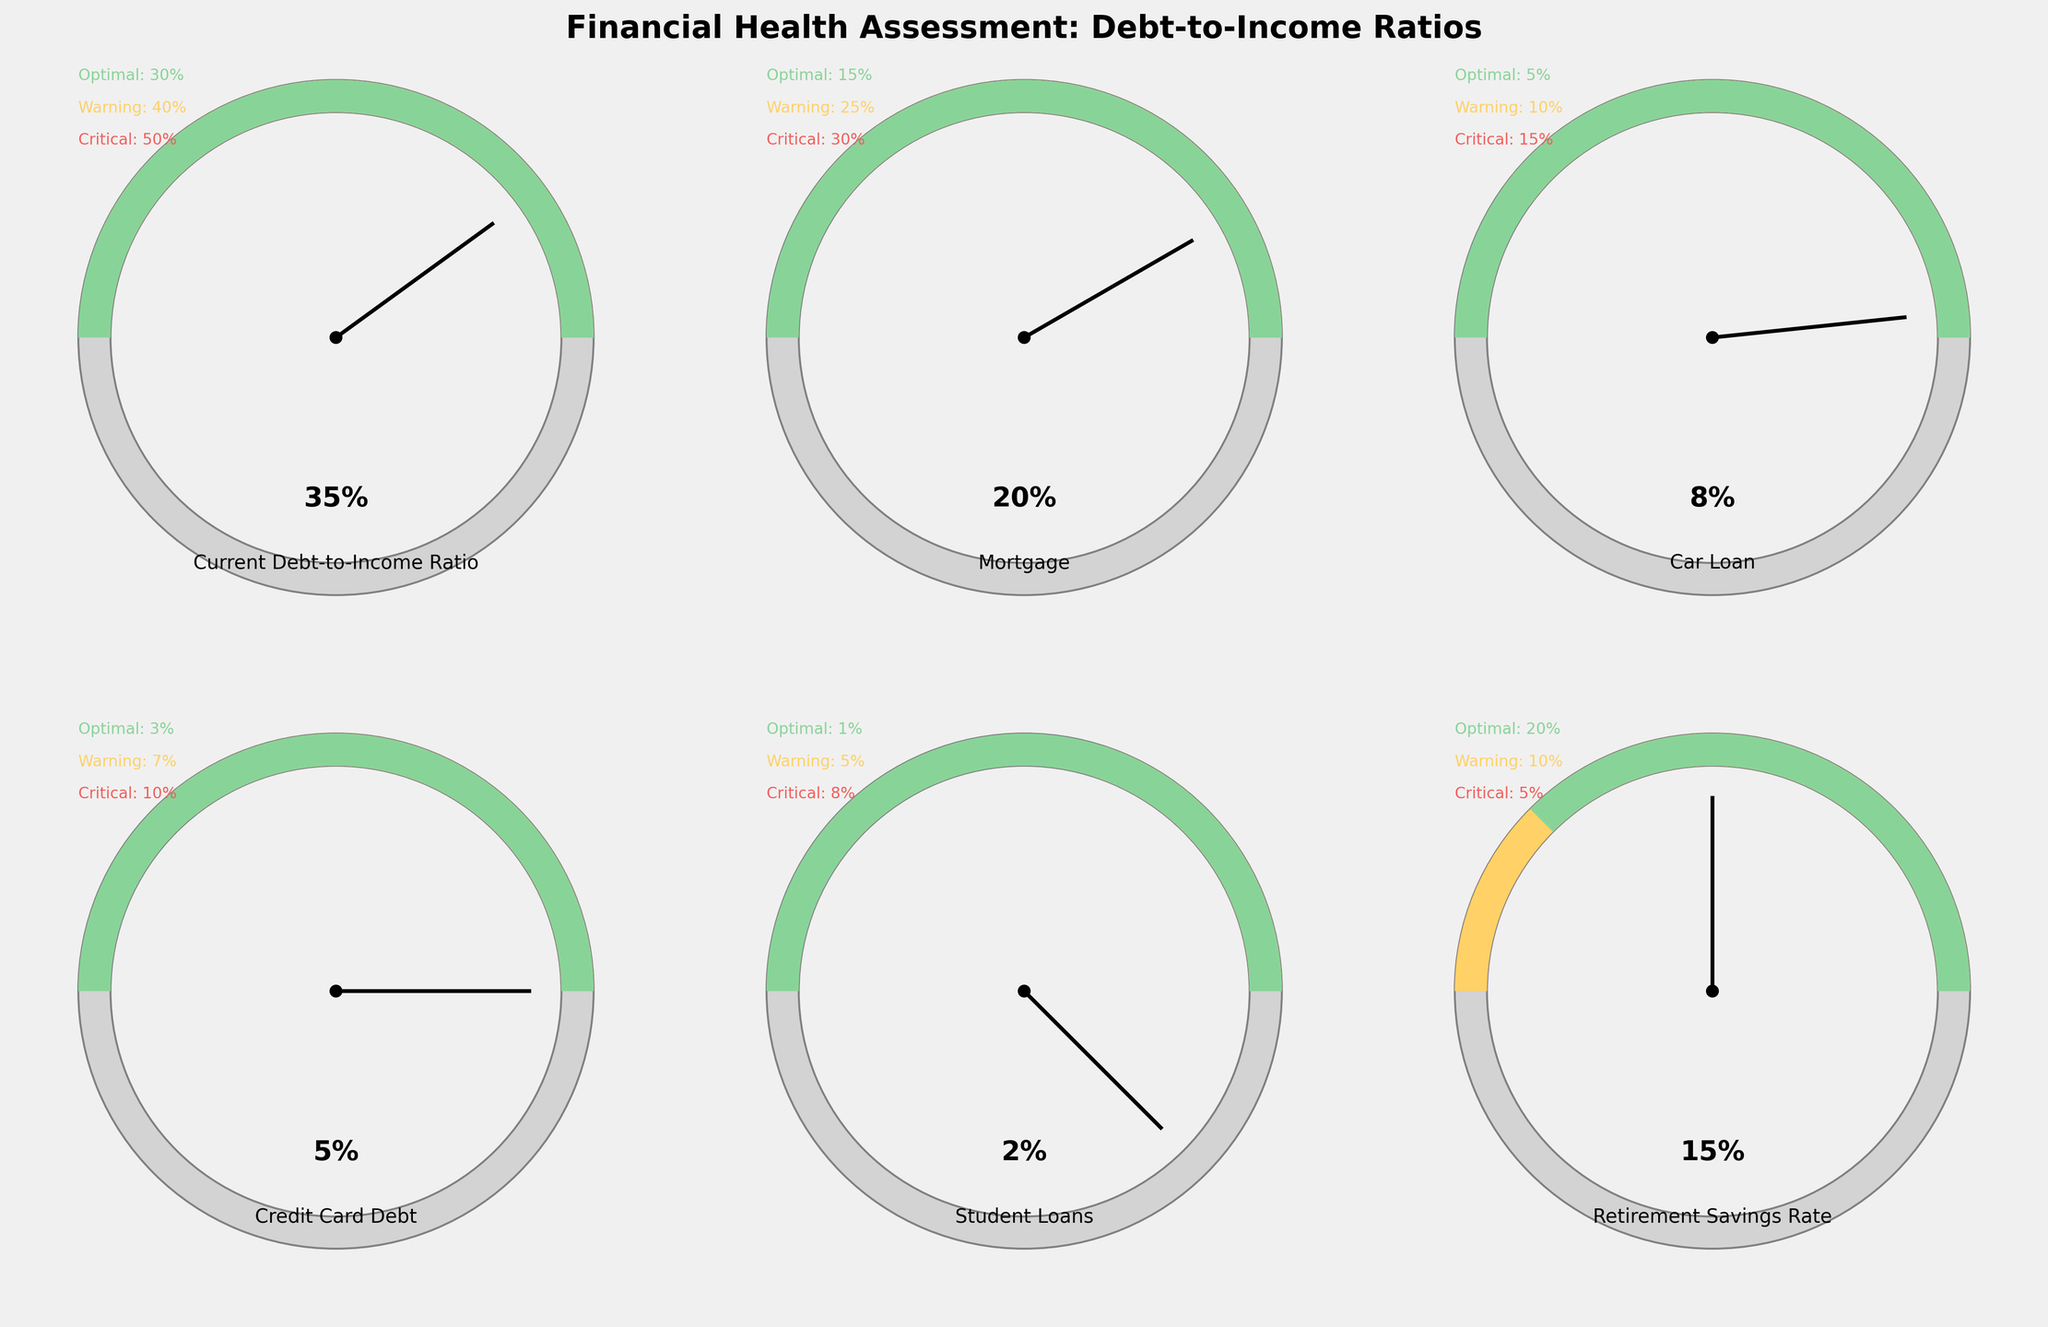What's the title of the figure? The title of the figure is displayed at the top of the plot in bold and large font. It reads "Financial Health Assessment: Debt-to-Income Ratios".
Answer: Financial Health Assessment: Debt-to-Income Ratios Which category has the highest optimal value? The optimal values for each category are shown as text in the gauge charts. The category with the highest optimal value is "Retirement Savings Rate" with an optimal value of 20%.
Answer: Retirement Savings Rate How many categories have an optimal value less than 10%? The optimal values for the categories are visible on the gauge charts as text. The only category with an optimal value less than 10% is "Student Loans" with an optimal value of 1%. Therefore, only one category meets this criterion.
Answer: 1 What is the current debt-to-income ratio for "Car Loan" and how does it compare to the warning level? The "Car Loan" category shows a current debt-to-income ratio of 8%, and the warning level for this category is 10%. Since 8% is less than 10%, it is below the warning level.
Answer: 8%, below the warning level List the categories and their current debt-to-income ratios, starting from the highest to the lowest ratio. The current debt-to-income ratios for the categories are displayed within each gauge chart. Arranging them from highest to lowest: 
1. Current Debt-to-Income Ratio: 35%
2. Mortgage: 20%
3. Car Loan: 8%
4. Credit Card Debt: 5%
5. Student Loans: 2%
6. Retirement Savings Rate: 15% (inverse for savings rate)
Answer: 35%, 20%, 8%, 5%, 2%, 15% Is the current "Credit Card Debt" percentage in the optimal, warning, or critical zone? For "Credit Card Debt," the optimal value is 3%, the warning value is 7%, and the critical value is 10%. The current value is 5%, which falls between 3% and 7%, placing it in the warning zone.
Answer: Warning zone 